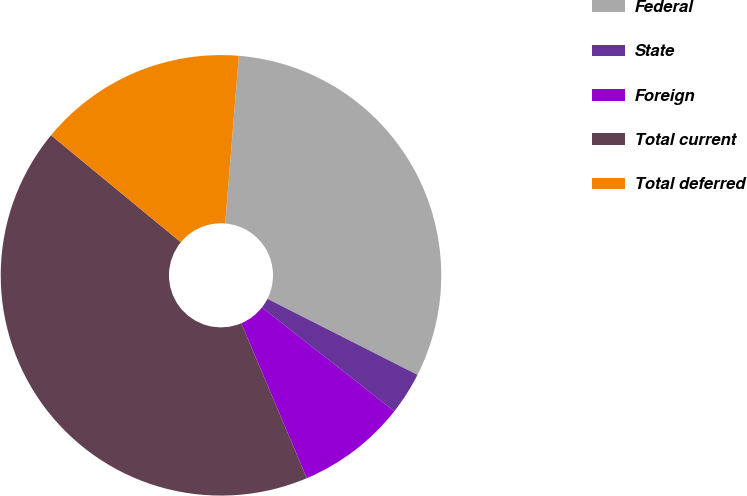Convert chart. <chart><loc_0><loc_0><loc_500><loc_500><pie_chart><fcel>Federal<fcel>State<fcel>Foreign<fcel>Total current<fcel>Total deferred<nl><fcel>31.17%<fcel>3.12%<fcel>8.05%<fcel>42.34%<fcel>15.32%<nl></chart> 